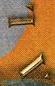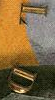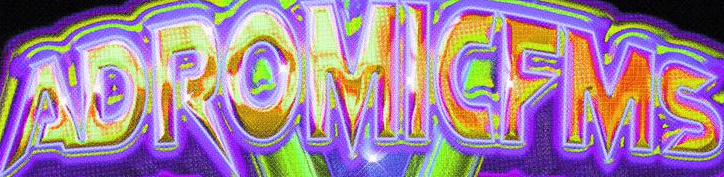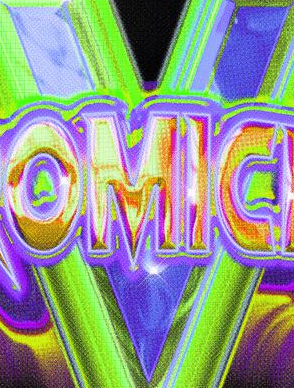Identify the words shown in these images in order, separated by a semicolon. AL; LD; ADROMICFMS; V 